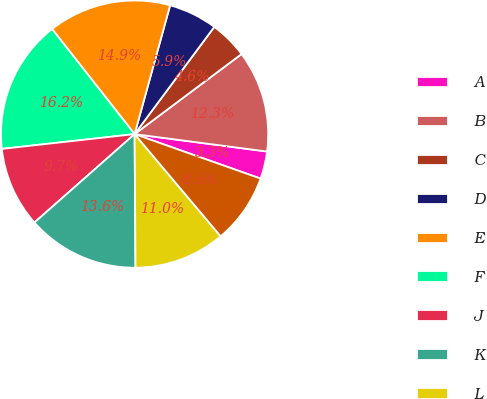Convert chart. <chart><loc_0><loc_0><loc_500><loc_500><pie_chart><fcel>A<fcel>B<fcel>C<fcel>D<fcel>E<fcel>F<fcel>J<fcel>K<fcel>L<fcel>M<nl><fcel>3.32%<fcel>12.31%<fcel>4.6%<fcel>5.89%<fcel>14.88%<fcel>16.17%<fcel>9.74%<fcel>13.6%<fcel>11.03%<fcel>8.46%<nl></chart> 